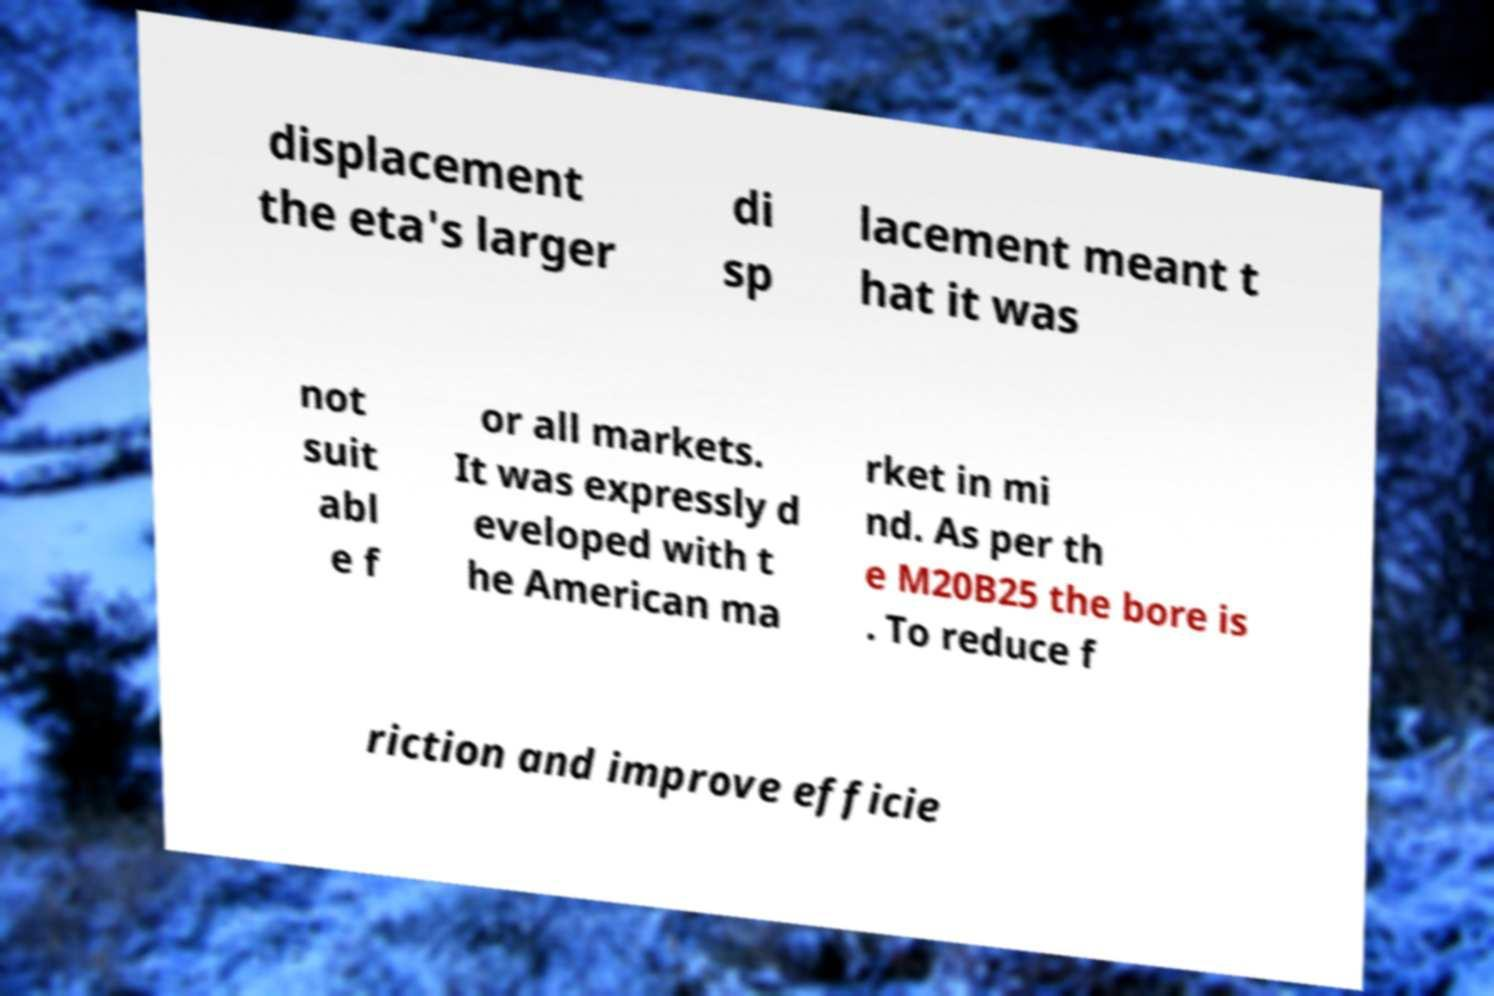Could you assist in decoding the text presented in this image and type it out clearly? displacement the eta's larger di sp lacement meant t hat it was not suit abl e f or all markets. It was expressly d eveloped with t he American ma rket in mi nd. As per th e M20B25 the bore is . To reduce f riction and improve efficie 